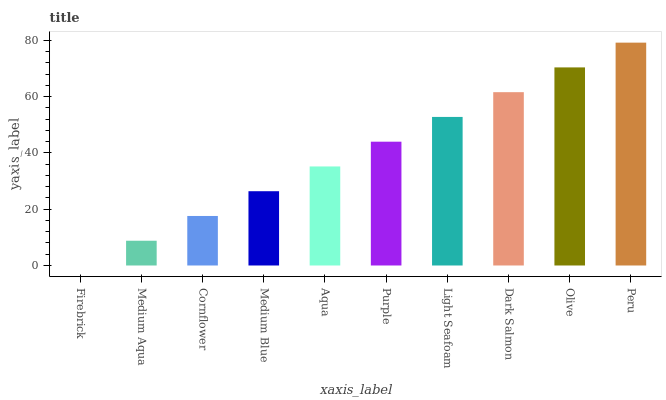Is Firebrick the minimum?
Answer yes or no. Yes. Is Peru the maximum?
Answer yes or no. Yes. Is Medium Aqua the minimum?
Answer yes or no. No. Is Medium Aqua the maximum?
Answer yes or no. No. Is Medium Aqua greater than Firebrick?
Answer yes or no. Yes. Is Firebrick less than Medium Aqua?
Answer yes or no. Yes. Is Firebrick greater than Medium Aqua?
Answer yes or no. No. Is Medium Aqua less than Firebrick?
Answer yes or no. No. Is Purple the high median?
Answer yes or no. Yes. Is Aqua the low median?
Answer yes or no. Yes. Is Medium Aqua the high median?
Answer yes or no. No. Is Medium Aqua the low median?
Answer yes or no. No. 